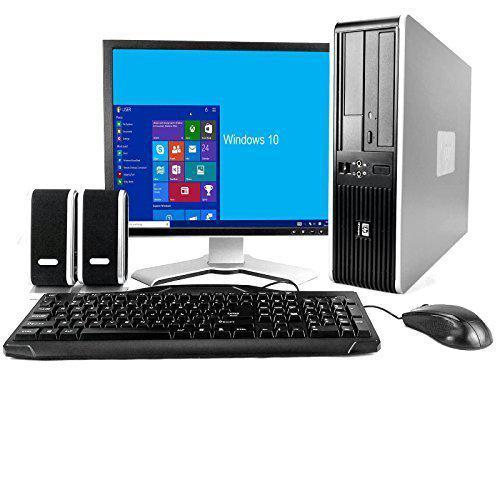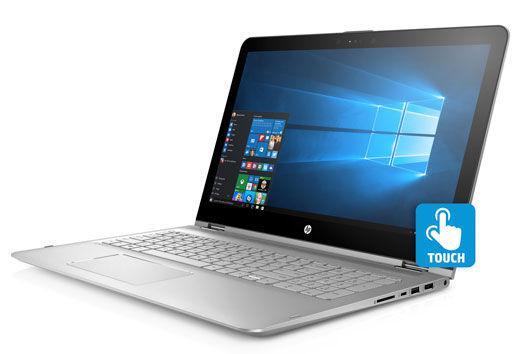The first image is the image on the left, the second image is the image on the right. Considering the images on both sides, is "The screen on the left is displayed head-on, and the screen on the right is angled facing left." valid? Answer yes or no. Yes. The first image is the image on the left, the second image is the image on the right. For the images shown, is this caption "In at least one image there is one powered on laptop that top side is black and base is silver." true? Answer yes or no. Yes. 